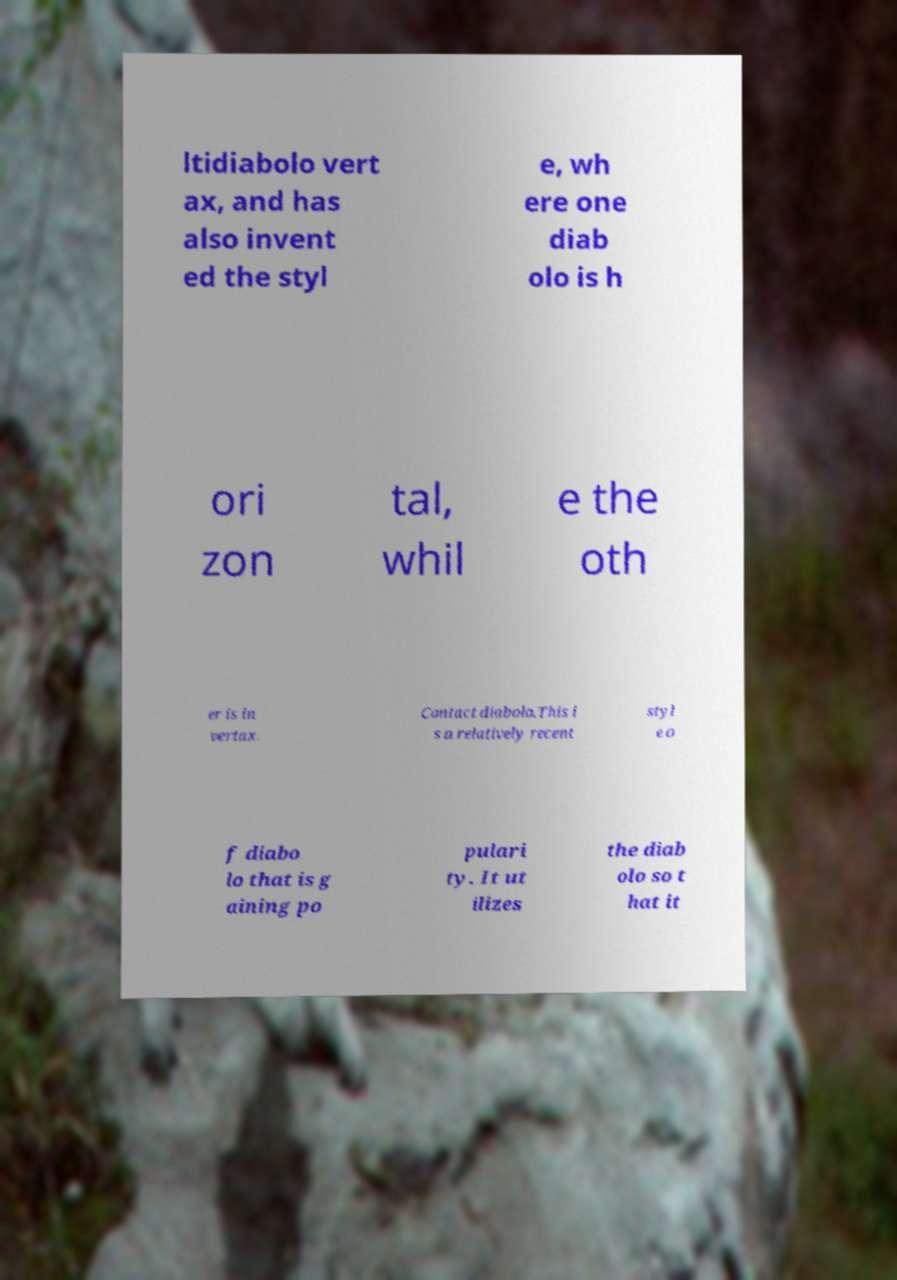Could you assist in decoding the text presented in this image and type it out clearly? ltidiabolo vert ax, and has also invent ed the styl e, wh ere one diab olo is h ori zon tal, whil e the oth er is in vertax. Contact diabolo.This i s a relatively recent styl e o f diabo lo that is g aining po pulari ty. It ut ilizes the diab olo so t hat it 